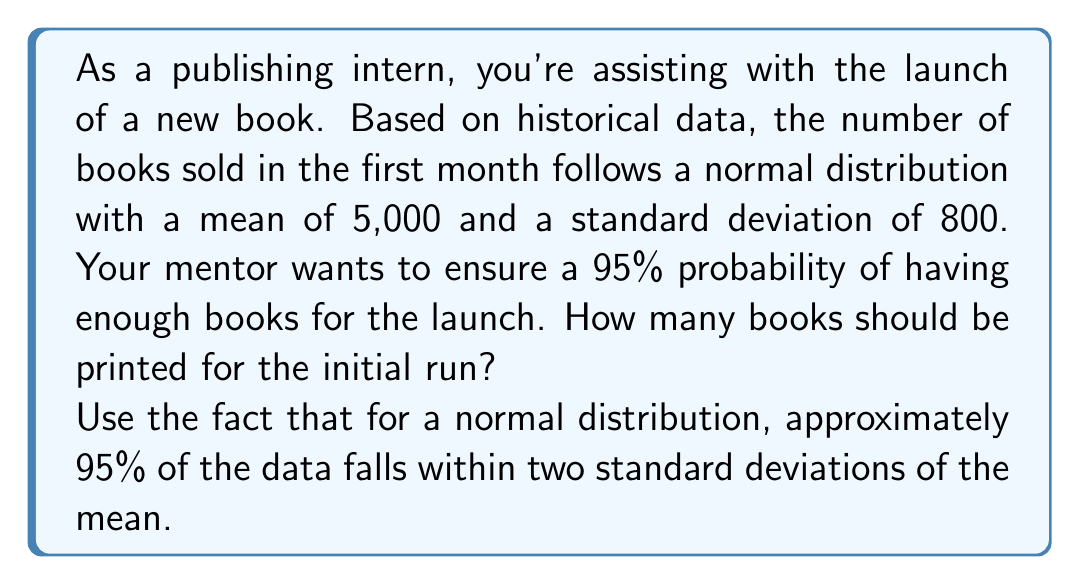Help me with this question. To solve this problem, we'll use the properties of the normal distribution and the concept of z-scores.

1) We know that for a normal distribution, approximately 95% of the data falls within two standard deviations of the mean. This means we need to calculate the value that is two standard deviations above the mean.

2) The formula for this is:
   $$X = \mu + Z\sigma$$
   Where:
   $X$ is the value we're looking for
   $\mu$ is the mean
   $Z$ is the number of standard deviations (2 in this case)
   $\sigma$ is the standard deviation

3) Let's plug in our values:
   $\mu = 5000$
   $Z = 2$ (for 95% probability)
   $\sigma = 800$

4) Now we can calculate:
   $$X = 5000 + 2(800)$$
   $$X = 5000 + 1600$$
   $$X = 6600$$

5) To ensure we have enough books with 95% probability, we should round up to the nearest hundred.
Answer: 6,600 books (rounded up to 6,700 for practical purposes) 